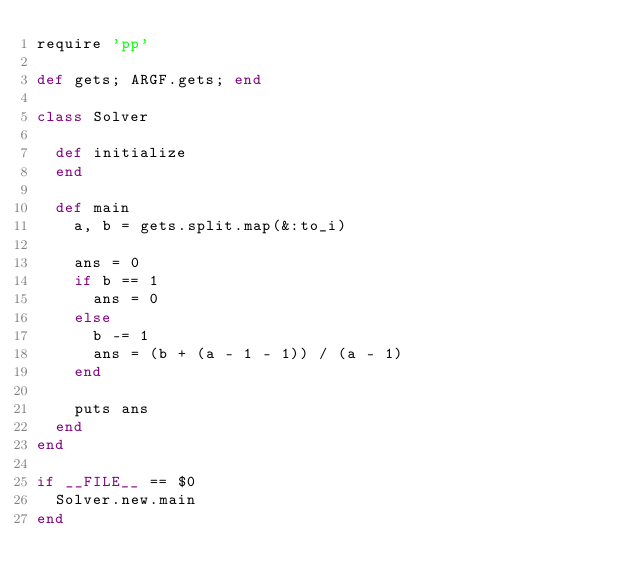Convert code to text. <code><loc_0><loc_0><loc_500><loc_500><_Ruby_>require 'pp'

def gets; ARGF.gets; end

class Solver

  def initialize
  end

  def main
    a, b = gets.split.map(&:to_i)

    ans = 0
    if b == 1
      ans = 0
    else
      b -= 1
      ans = (b + (a - 1 - 1)) / (a - 1)
    end

    puts ans
  end
end

if __FILE__ == $0
  Solver.new.main
end
</code> 